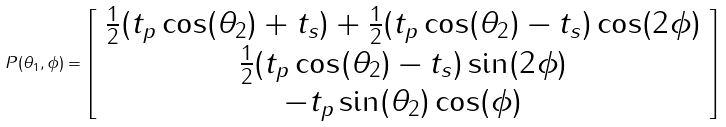<formula> <loc_0><loc_0><loc_500><loc_500>P ( \theta _ { 1 } , \phi ) = \left [ \begin{array} { c c c } \frac { 1 } { 2 } ( t _ { p } \cos ( \theta _ { 2 } ) + t _ { s } ) + \frac { 1 } { 2 } ( t _ { p } \cos ( \theta _ { 2 } ) - t _ { s } ) \cos ( 2 \phi ) \\ \frac { 1 } { 2 } ( t _ { p } \cos ( \theta _ { 2 } ) - t _ { s } ) \sin ( 2 \phi ) \\ - t _ { p } \sin ( \theta _ { 2 } ) \cos ( \phi ) \\ \end{array} \right ]</formula> 